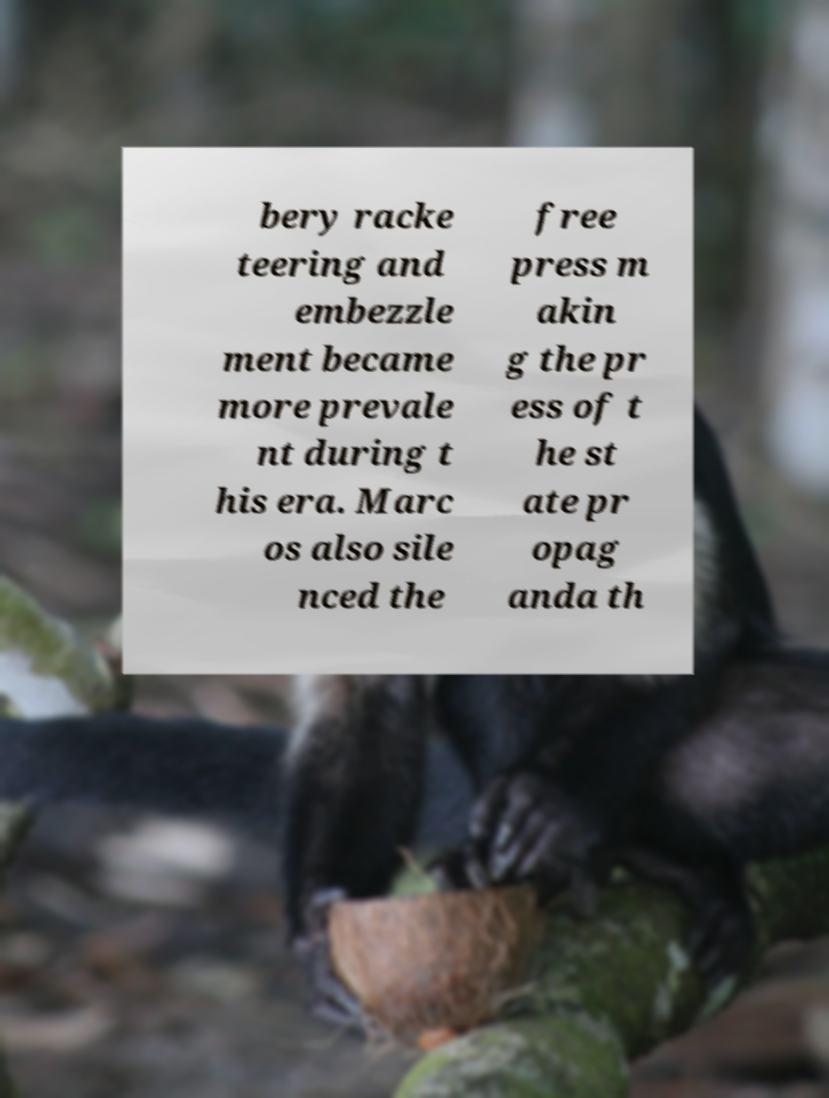Please identify and transcribe the text found in this image. bery racke teering and embezzle ment became more prevale nt during t his era. Marc os also sile nced the free press m akin g the pr ess of t he st ate pr opag anda th 